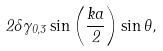Convert formula to latex. <formula><loc_0><loc_0><loc_500><loc_500>2 \delta \gamma _ { 0 , 3 } \sin \left ( \frac { k a } { 2 } \right ) \sin \theta ,</formula> 